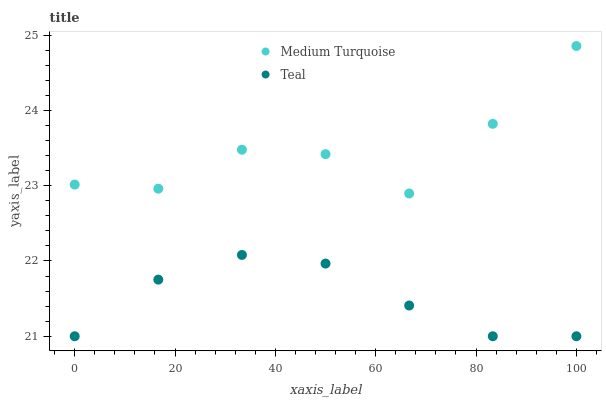Does Teal have the minimum area under the curve?
Answer yes or no. Yes. Does Medium Turquoise have the maximum area under the curve?
Answer yes or no. Yes. Does Medium Turquoise have the minimum area under the curve?
Answer yes or no. No. Is Teal the smoothest?
Answer yes or no. Yes. Is Medium Turquoise the roughest?
Answer yes or no. Yes. Is Medium Turquoise the smoothest?
Answer yes or no. No. Does Teal have the lowest value?
Answer yes or no. Yes. Does Medium Turquoise have the lowest value?
Answer yes or no. No. Does Medium Turquoise have the highest value?
Answer yes or no. Yes. Is Teal less than Medium Turquoise?
Answer yes or no. Yes. Is Medium Turquoise greater than Teal?
Answer yes or no. Yes. Does Teal intersect Medium Turquoise?
Answer yes or no. No. 